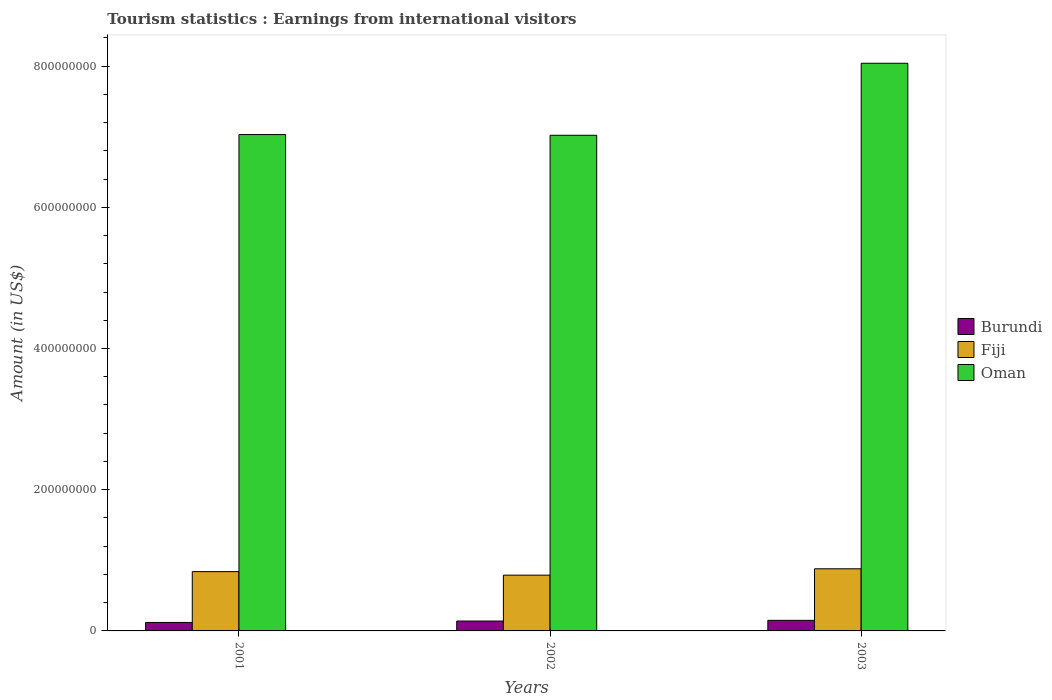Are the number of bars per tick equal to the number of legend labels?
Keep it short and to the point. Yes. How many bars are there on the 2nd tick from the right?
Keep it short and to the point. 3. What is the label of the 1st group of bars from the left?
Keep it short and to the point. 2001. What is the earnings from international visitors in Burundi in 2001?
Your answer should be very brief. 1.20e+07. Across all years, what is the maximum earnings from international visitors in Burundi?
Offer a terse response. 1.50e+07. Across all years, what is the minimum earnings from international visitors in Burundi?
Your answer should be very brief. 1.20e+07. In which year was the earnings from international visitors in Fiji maximum?
Your answer should be compact. 2003. What is the total earnings from international visitors in Fiji in the graph?
Give a very brief answer. 2.51e+08. What is the difference between the earnings from international visitors in Burundi in 2002 and that in 2003?
Your answer should be compact. -1.00e+06. What is the difference between the earnings from international visitors in Burundi in 2001 and the earnings from international visitors in Fiji in 2002?
Provide a succinct answer. -6.70e+07. What is the average earnings from international visitors in Oman per year?
Offer a very short reply. 7.36e+08. In the year 2003, what is the difference between the earnings from international visitors in Burundi and earnings from international visitors in Oman?
Provide a short and direct response. -7.89e+08. What is the ratio of the earnings from international visitors in Oman in 2002 to that in 2003?
Give a very brief answer. 0.87. Is the difference between the earnings from international visitors in Burundi in 2001 and 2002 greater than the difference between the earnings from international visitors in Oman in 2001 and 2002?
Offer a very short reply. No. What is the difference between the highest and the second highest earnings from international visitors in Oman?
Keep it short and to the point. 1.01e+08. What is the difference between the highest and the lowest earnings from international visitors in Oman?
Keep it short and to the point. 1.02e+08. In how many years, is the earnings from international visitors in Fiji greater than the average earnings from international visitors in Fiji taken over all years?
Ensure brevity in your answer.  2. What does the 3rd bar from the left in 2001 represents?
Make the answer very short. Oman. What does the 3rd bar from the right in 2002 represents?
Make the answer very short. Burundi. What is the difference between two consecutive major ticks on the Y-axis?
Keep it short and to the point. 2.00e+08. Does the graph contain grids?
Your answer should be compact. No. What is the title of the graph?
Provide a short and direct response. Tourism statistics : Earnings from international visitors. Does "Cameroon" appear as one of the legend labels in the graph?
Provide a short and direct response. No. What is the Amount (in US$) of Fiji in 2001?
Provide a short and direct response. 8.40e+07. What is the Amount (in US$) of Oman in 2001?
Keep it short and to the point. 7.03e+08. What is the Amount (in US$) in Burundi in 2002?
Give a very brief answer. 1.40e+07. What is the Amount (in US$) in Fiji in 2002?
Your answer should be compact. 7.90e+07. What is the Amount (in US$) in Oman in 2002?
Offer a very short reply. 7.02e+08. What is the Amount (in US$) in Burundi in 2003?
Ensure brevity in your answer.  1.50e+07. What is the Amount (in US$) of Fiji in 2003?
Offer a very short reply. 8.80e+07. What is the Amount (in US$) in Oman in 2003?
Give a very brief answer. 8.04e+08. Across all years, what is the maximum Amount (in US$) in Burundi?
Your answer should be very brief. 1.50e+07. Across all years, what is the maximum Amount (in US$) of Fiji?
Offer a terse response. 8.80e+07. Across all years, what is the maximum Amount (in US$) of Oman?
Your answer should be compact. 8.04e+08. Across all years, what is the minimum Amount (in US$) of Fiji?
Your response must be concise. 7.90e+07. Across all years, what is the minimum Amount (in US$) in Oman?
Your response must be concise. 7.02e+08. What is the total Amount (in US$) in Burundi in the graph?
Make the answer very short. 4.10e+07. What is the total Amount (in US$) in Fiji in the graph?
Offer a terse response. 2.51e+08. What is the total Amount (in US$) in Oman in the graph?
Make the answer very short. 2.21e+09. What is the difference between the Amount (in US$) of Fiji in 2001 and that in 2002?
Provide a short and direct response. 5.00e+06. What is the difference between the Amount (in US$) in Burundi in 2001 and that in 2003?
Ensure brevity in your answer.  -3.00e+06. What is the difference between the Amount (in US$) of Fiji in 2001 and that in 2003?
Keep it short and to the point. -4.00e+06. What is the difference between the Amount (in US$) of Oman in 2001 and that in 2003?
Provide a short and direct response. -1.01e+08. What is the difference between the Amount (in US$) of Fiji in 2002 and that in 2003?
Keep it short and to the point. -9.00e+06. What is the difference between the Amount (in US$) of Oman in 2002 and that in 2003?
Ensure brevity in your answer.  -1.02e+08. What is the difference between the Amount (in US$) in Burundi in 2001 and the Amount (in US$) in Fiji in 2002?
Your response must be concise. -6.70e+07. What is the difference between the Amount (in US$) in Burundi in 2001 and the Amount (in US$) in Oman in 2002?
Your response must be concise. -6.90e+08. What is the difference between the Amount (in US$) of Fiji in 2001 and the Amount (in US$) of Oman in 2002?
Give a very brief answer. -6.18e+08. What is the difference between the Amount (in US$) of Burundi in 2001 and the Amount (in US$) of Fiji in 2003?
Provide a short and direct response. -7.60e+07. What is the difference between the Amount (in US$) of Burundi in 2001 and the Amount (in US$) of Oman in 2003?
Ensure brevity in your answer.  -7.92e+08. What is the difference between the Amount (in US$) in Fiji in 2001 and the Amount (in US$) in Oman in 2003?
Your response must be concise. -7.20e+08. What is the difference between the Amount (in US$) of Burundi in 2002 and the Amount (in US$) of Fiji in 2003?
Your response must be concise. -7.40e+07. What is the difference between the Amount (in US$) of Burundi in 2002 and the Amount (in US$) of Oman in 2003?
Your response must be concise. -7.90e+08. What is the difference between the Amount (in US$) of Fiji in 2002 and the Amount (in US$) of Oman in 2003?
Ensure brevity in your answer.  -7.25e+08. What is the average Amount (in US$) of Burundi per year?
Provide a short and direct response. 1.37e+07. What is the average Amount (in US$) in Fiji per year?
Offer a terse response. 8.37e+07. What is the average Amount (in US$) in Oman per year?
Provide a short and direct response. 7.36e+08. In the year 2001, what is the difference between the Amount (in US$) in Burundi and Amount (in US$) in Fiji?
Your answer should be compact. -7.20e+07. In the year 2001, what is the difference between the Amount (in US$) in Burundi and Amount (in US$) in Oman?
Give a very brief answer. -6.91e+08. In the year 2001, what is the difference between the Amount (in US$) of Fiji and Amount (in US$) of Oman?
Keep it short and to the point. -6.19e+08. In the year 2002, what is the difference between the Amount (in US$) of Burundi and Amount (in US$) of Fiji?
Keep it short and to the point. -6.50e+07. In the year 2002, what is the difference between the Amount (in US$) of Burundi and Amount (in US$) of Oman?
Provide a succinct answer. -6.88e+08. In the year 2002, what is the difference between the Amount (in US$) in Fiji and Amount (in US$) in Oman?
Give a very brief answer. -6.23e+08. In the year 2003, what is the difference between the Amount (in US$) in Burundi and Amount (in US$) in Fiji?
Keep it short and to the point. -7.30e+07. In the year 2003, what is the difference between the Amount (in US$) in Burundi and Amount (in US$) in Oman?
Provide a short and direct response. -7.89e+08. In the year 2003, what is the difference between the Amount (in US$) in Fiji and Amount (in US$) in Oman?
Keep it short and to the point. -7.16e+08. What is the ratio of the Amount (in US$) of Burundi in 2001 to that in 2002?
Provide a succinct answer. 0.86. What is the ratio of the Amount (in US$) of Fiji in 2001 to that in 2002?
Ensure brevity in your answer.  1.06. What is the ratio of the Amount (in US$) in Fiji in 2001 to that in 2003?
Offer a terse response. 0.95. What is the ratio of the Amount (in US$) in Oman in 2001 to that in 2003?
Ensure brevity in your answer.  0.87. What is the ratio of the Amount (in US$) of Fiji in 2002 to that in 2003?
Your answer should be very brief. 0.9. What is the ratio of the Amount (in US$) of Oman in 2002 to that in 2003?
Provide a succinct answer. 0.87. What is the difference between the highest and the second highest Amount (in US$) of Fiji?
Give a very brief answer. 4.00e+06. What is the difference between the highest and the second highest Amount (in US$) of Oman?
Offer a terse response. 1.01e+08. What is the difference between the highest and the lowest Amount (in US$) of Fiji?
Keep it short and to the point. 9.00e+06. What is the difference between the highest and the lowest Amount (in US$) of Oman?
Provide a succinct answer. 1.02e+08. 